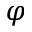<formula> <loc_0><loc_0><loc_500><loc_500>\varphi</formula> 